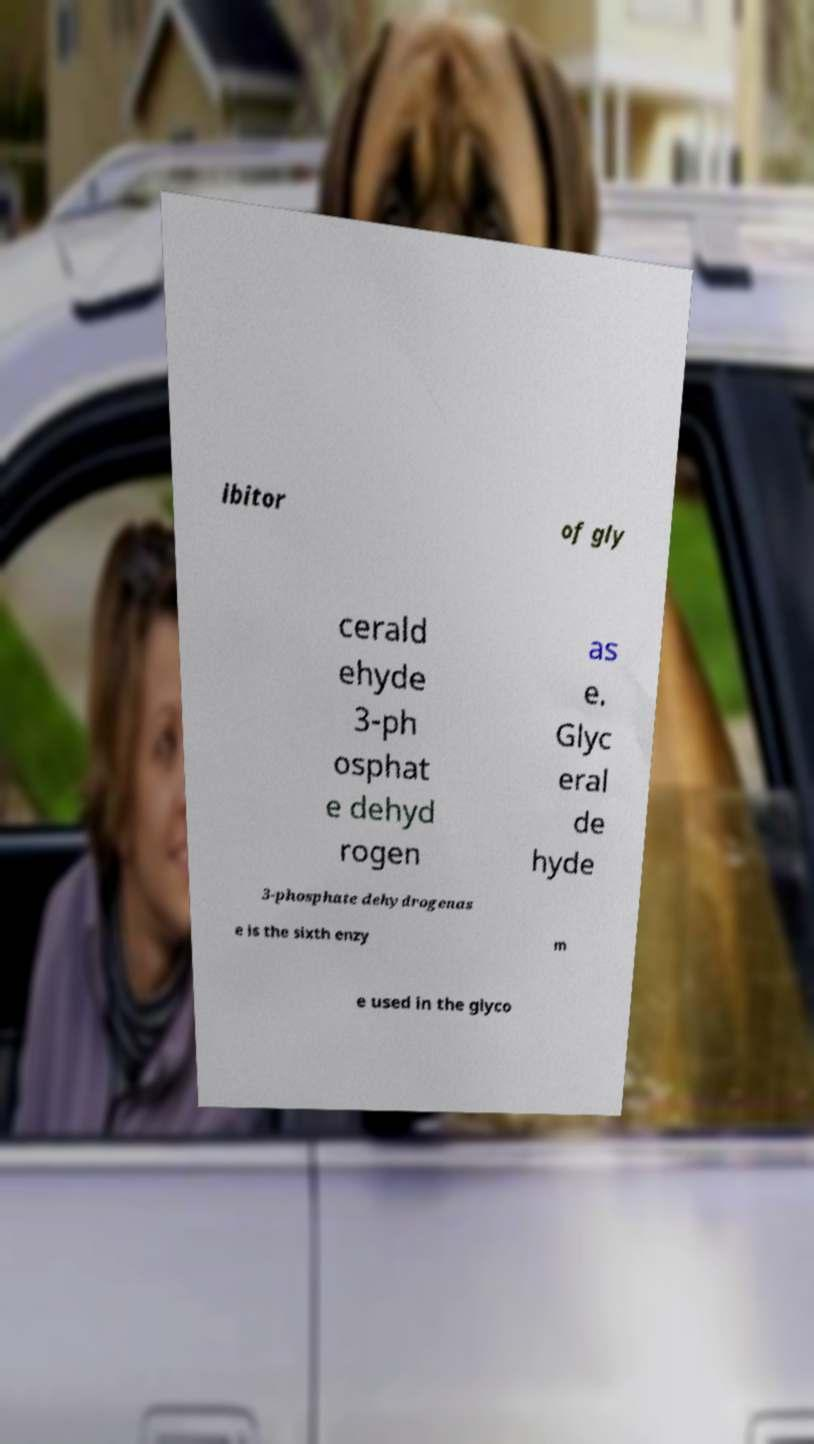Could you assist in decoding the text presented in this image and type it out clearly? ibitor of gly cerald ehyde 3-ph osphat e dehyd rogen as e. Glyc eral de hyde 3-phosphate dehydrogenas e is the sixth enzy m e used in the glyco 